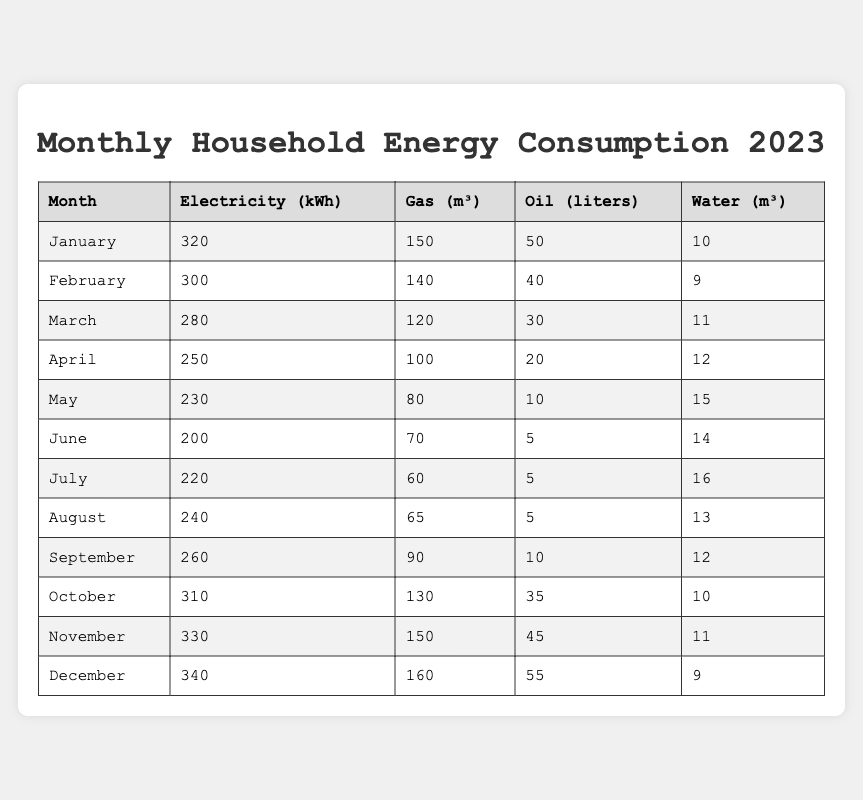What was the highest electricity consumption in a month? Looking through the table, December shows the highest electricity consumption at 340 kWh.
Answer: 340 kWh Which month had the lowest gas consumption? Upon reviewing the table, we see that June had the least gas consumption with 70 m³.
Answer: 70 m³ How much oil was consumed in May? Checking the table, I find that May had an oil consumption of 10 liters.
Answer: 10 liters What is the total water consumption for the first half of the year (January to June)? Adding the water consumption values for January (10), February (9), March (11), April (12), May (15), and June (14): 10 + 9 + 11 + 12 + 15 + 14 = 71 m³ total.
Answer: 71 m³ In which month did the household consume the most gas? By examining the table, it is clear that December had the highest gas consumption at 160 m³.
Answer: 160 m³ What is the average electricity consumption from January to June? To find the average, first add the electricity values for each month: 320 + 300 + 280 + 250 + 230 + 200 = 1580 kWh, then divide by 6 months: 1580 / 6 = 263.33 kWh.
Answer: 263.33 kWh Was oil consumption higher in November compared to April? In the table, November shows an oil consumption of 45 liters, while April had only 20 liters, thus November had more oil consumption than April.
Answer: Yes How does the total energy consumption (sum of electricity, gas, oil, and water) in December compare with January? Calculate December's total: 340 kWh + 160 m³ + 55 liters + 9 m³ = 564 (assuming conversions for gas and oil are consistent) and January's total: 320 + 150 + 50 + 10 = 530. Since 564 > 530, December had a higher total energy consumption.
Answer: December had a higher total What was the difference in electricity consumption between the months of July and January? January's consumption is 320 kWh and July's is 220 kWh, so the difference is 320 - 220 = 100 kWh.
Answer: 100 kWh Which month had the highest oil consumption and how much was it? Looking at the table, December had the highest oil consumption of 55 liters.
Answer: 55 liters 